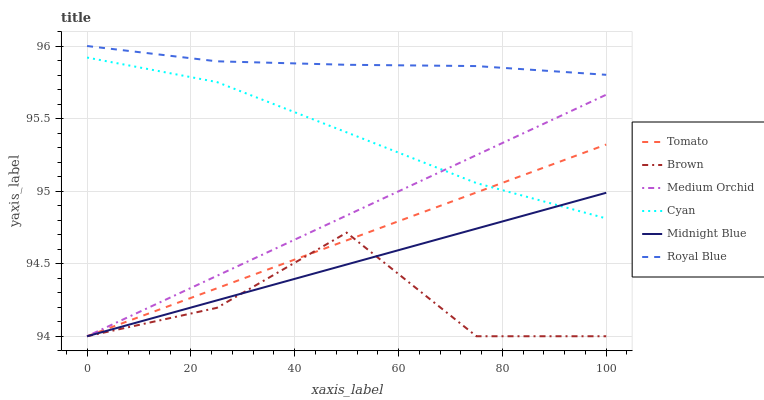Does Brown have the minimum area under the curve?
Answer yes or no. Yes. Does Royal Blue have the maximum area under the curve?
Answer yes or no. Yes. Does Midnight Blue have the minimum area under the curve?
Answer yes or no. No. Does Midnight Blue have the maximum area under the curve?
Answer yes or no. No. Is Tomato the smoothest?
Answer yes or no. Yes. Is Brown the roughest?
Answer yes or no. Yes. Is Midnight Blue the smoothest?
Answer yes or no. No. Is Midnight Blue the roughest?
Answer yes or no. No. Does Royal Blue have the lowest value?
Answer yes or no. No. Does Royal Blue have the highest value?
Answer yes or no. Yes. Does Midnight Blue have the highest value?
Answer yes or no. No. Is Midnight Blue less than Royal Blue?
Answer yes or no. Yes. Is Royal Blue greater than Medium Orchid?
Answer yes or no. Yes. Does Cyan intersect Tomato?
Answer yes or no. Yes. Is Cyan less than Tomato?
Answer yes or no. No. Is Cyan greater than Tomato?
Answer yes or no. No. Does Midnight Blue intersect Royal Blue?
Answer yes or no. No. 